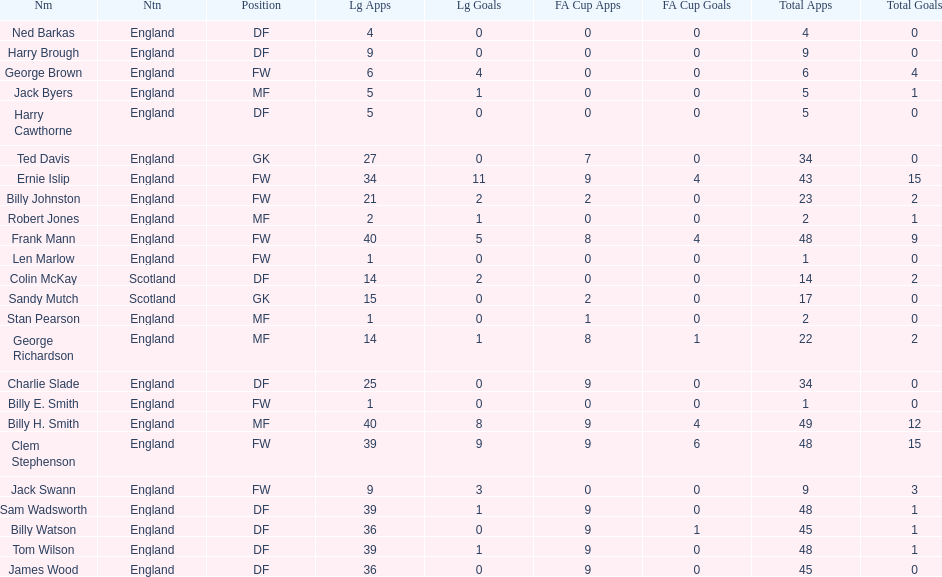What are the number of league apps ted davis has? 27. 